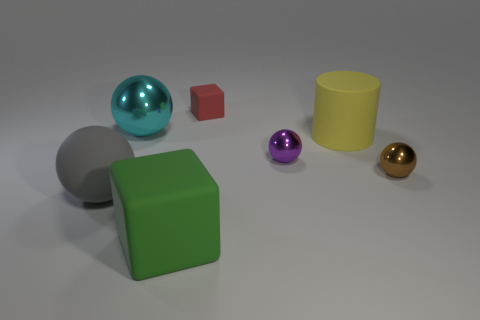Subtract 1 spheres. How many spheres are left? 3 Add 1 tiny metallic objects. How many objects exist? 8 Subtract all cylinders. How many objects are left? 6 Add 3 tiny shiny spheres. How many tiny shiny spheres are left? 5 Add 3 large green things. How many large green things exist? 4 Subtract 0 red cylinders. How many objects are left? 7 Subtract all big yellow rubber things. Subtract all green blocks. How many objects are left? 5 